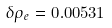Convert formula to latex. <formula><loc_0><loc_0><loc_500><loc_500>\delta \rho _ { e } = 0 . 0 0 5 3 1</formula> 